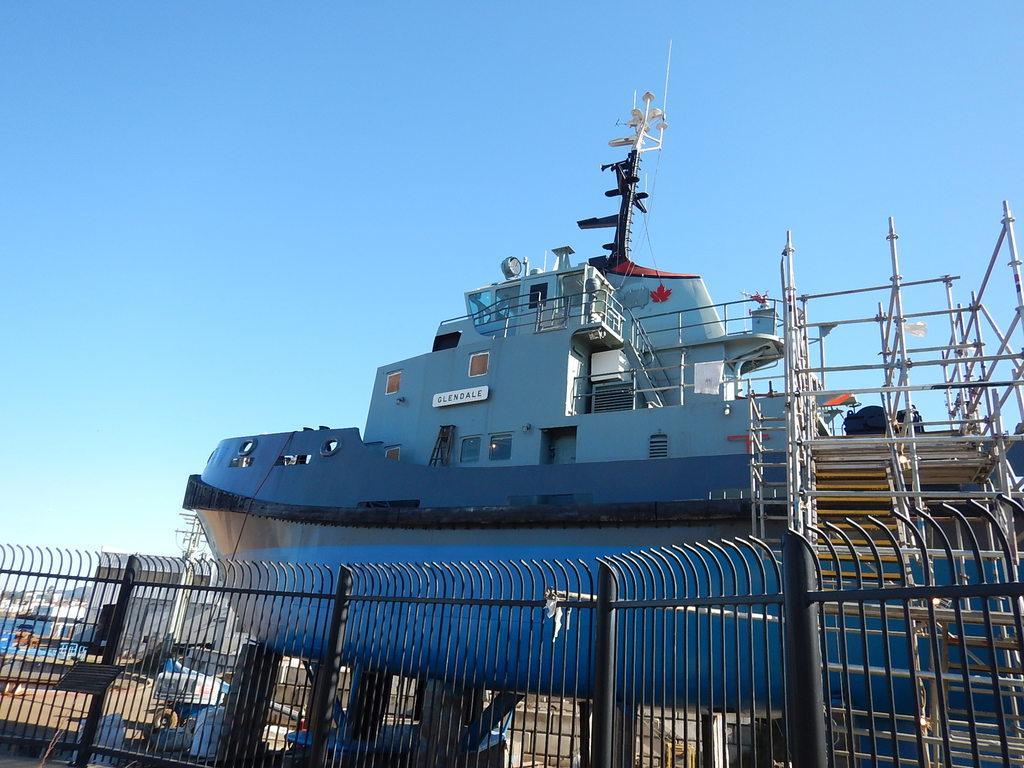Describe this image in one or two sentences. In the foreground of the picture it is railing. In the center of the picture there is a boat, vehicles, buildings and other objects. Sky is sunny. 